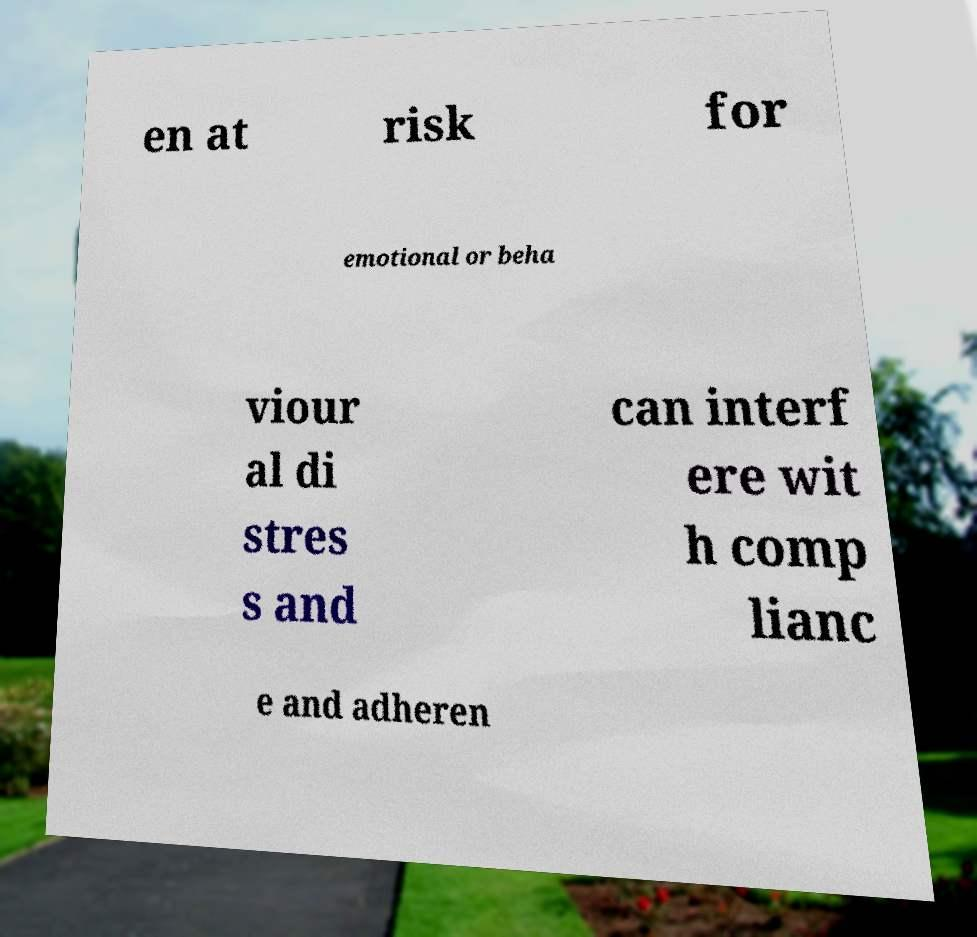Please read and relay the text visible in this image. What does it say? en at risk for emotional or beha viour al di stres s and can interf ere wit h comp lianc e and adheren 